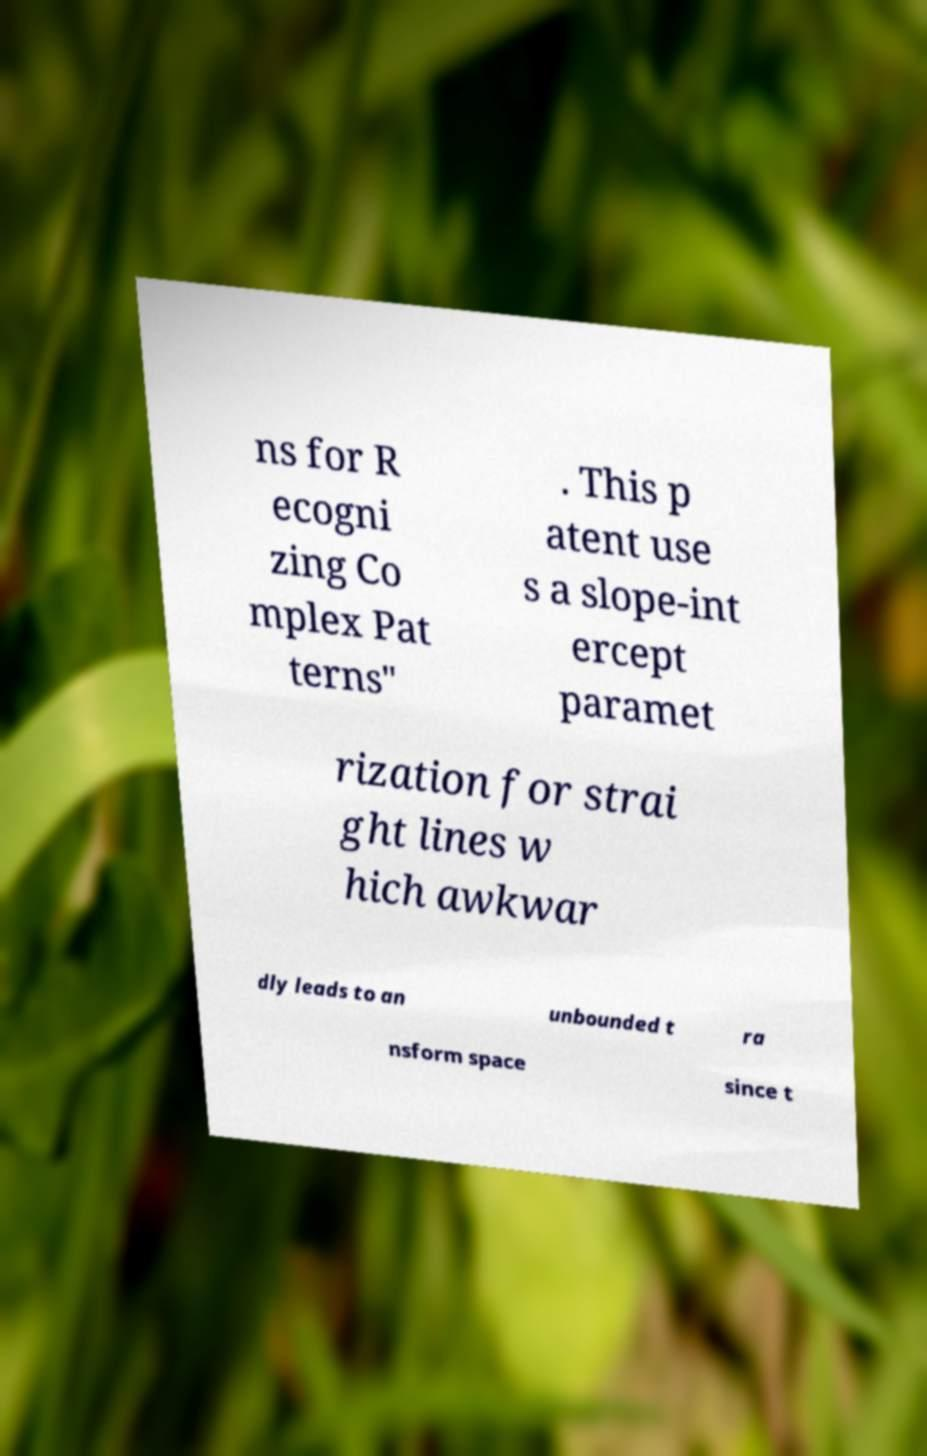Please identify and transcribe the text found in this image. ns for R ecogni zing Co mplex Pat terns" . This p atent use s a slope-int ercept paramet rization for strai ght lines w hich awkwar dly leads to an unbounded t ra nsform space since t 